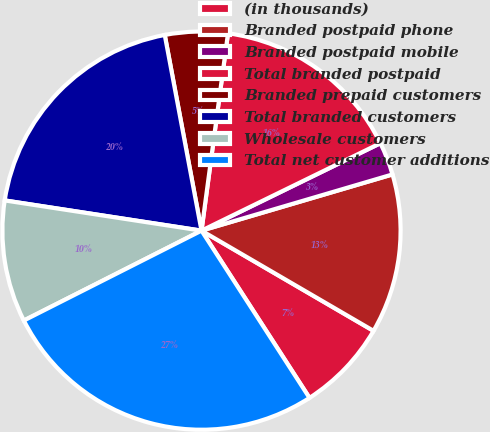<chart> <loc_0><loc_0><loc_500><loc_500><pie_chart><fcel>(in thousands)<fcel>Branded postpaid phone<fcel>Branded postpaid mobile<fcel>Total branded postpaid<fcel>Branded prepaid customers<fcel>Total branded customers<fcel>Wholesale customers<fcel>Total net customer additions<nl><fcel>7.48%<fcel>12.95%<fcel>2.68%<fcel>15.64%<fcel>5.08%<fcel>19.62%<fcel>9.88%<fcel>26.67%<nl></chart> 